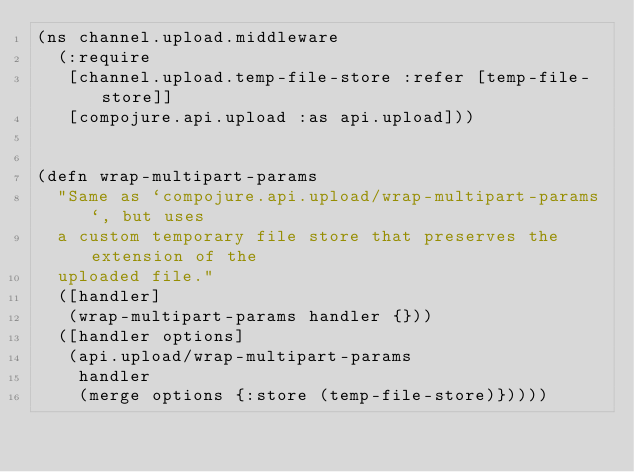Convert code to text. <code><loc_0><loc_0><loc_500><loc_500><_Clojure_>(ns channel.upload.middleware
  (:require
   [channel.upload.temp-file-store :refer [temp-file-store]]
   [compojure.api.upload :as api.upload]))


(defn wrap-multipart-params
  "Same as `compojure.api.upload/wrap-multipart-params`, but uses
  a custom temporary file store that preserves the extension of the
  uploaded file."
  ([handler]
   (wrap-multipart-params handler {}))
  ([handler options]
   (api.upload/wrap-multipart-params
    handler
    (merge options {:store (temp-file-store)}))))
</code> 